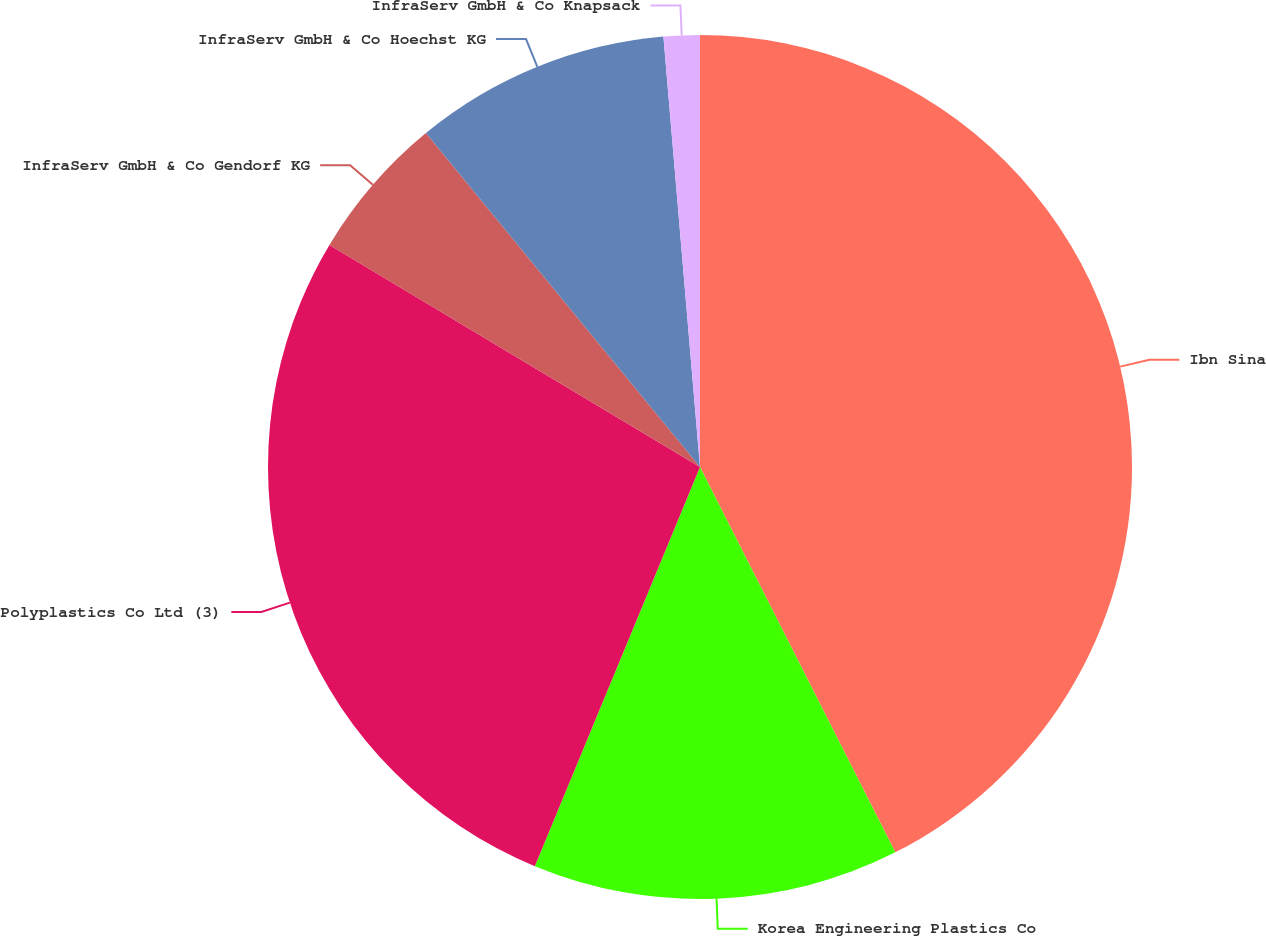Convert chart to OTSL. <chart><loc_0><loc_0><loc_500><loc_500><pie_chart><fcel>Ibn Sina<fcel>Korea Engineering Plastics Co<fcel>Polyplastics Co Ltd (3)<fcel>InfraServ GmbH & Co Gendorf KG<fcel>InfraServ GmbH & Co Hoechst KG<fcel>InfraServ GmbH & Co Knapsack<nl><fcel>42.54%<fcel>13.71%<fcel>27.35%<fcel>5.47%<fcel>9.59%<fcel>1.35%<nl></chart> 